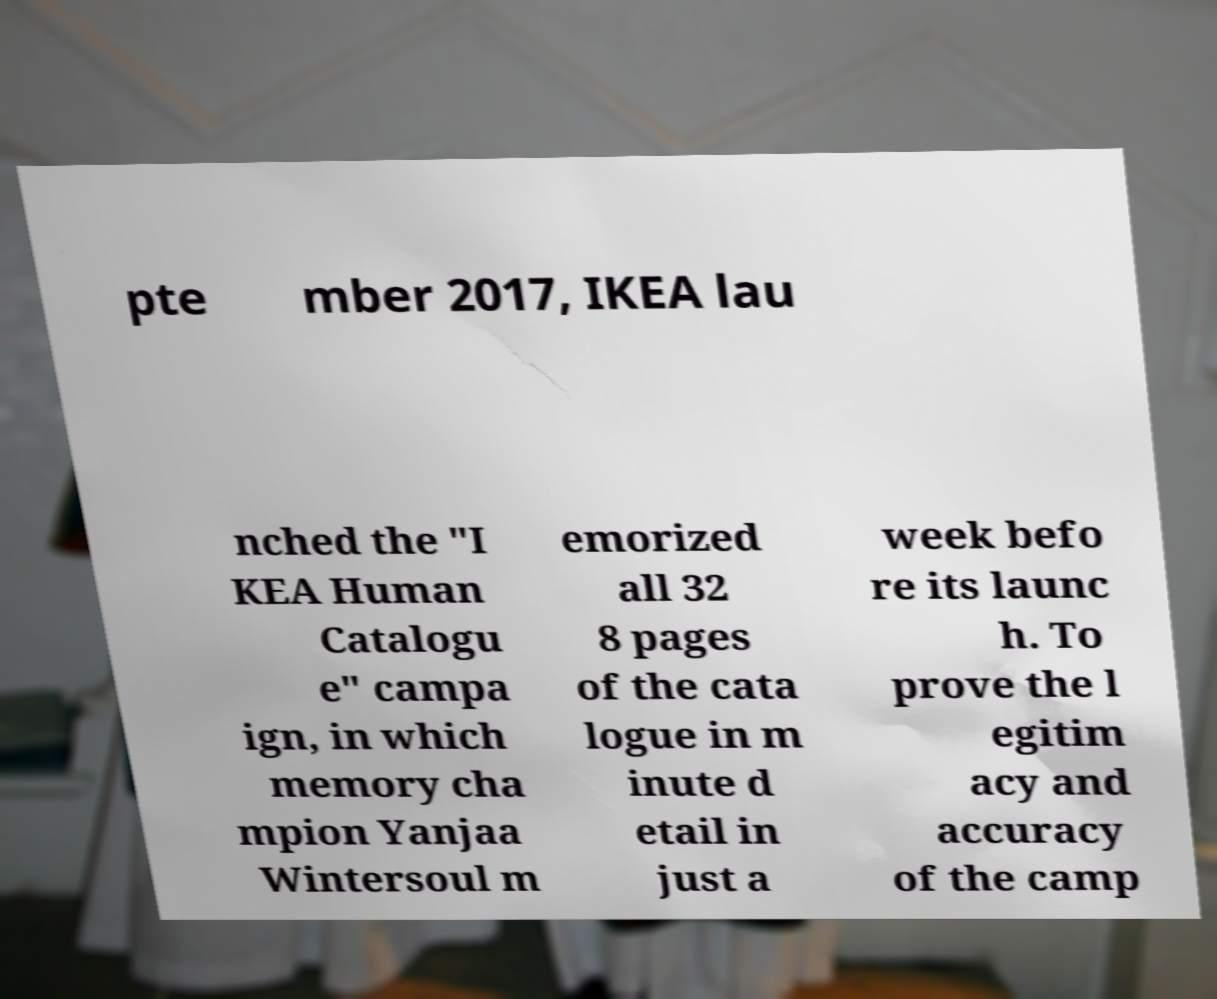Please read and relay the text visible in this image. What does it say? pte mber 2017, IKEA lau nched the "I KEA Human Catalogu e" campa ign, in which memory cha mpion Yanjaa Wintersoul m emorized all 32 8 pages of the cata logue in m inute d etail in just a week befo re its launc h. To prove the l egitim acy and accuracy of the camp 